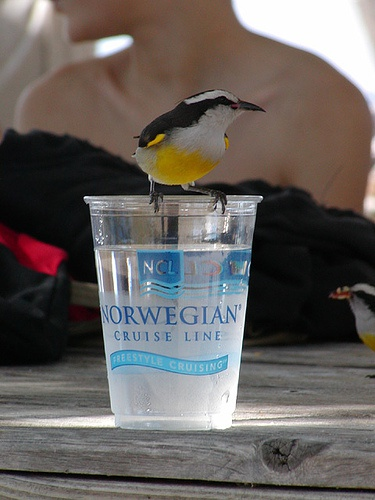Describe the objects in this image and their specific colors. I can see people in gray, black, brown, and maroon tones, cup in gray, darkgray, and lightgray tones, bird in gray, black, and olive tones, and bird in gray, black, olive, and maroon tones in this image. 